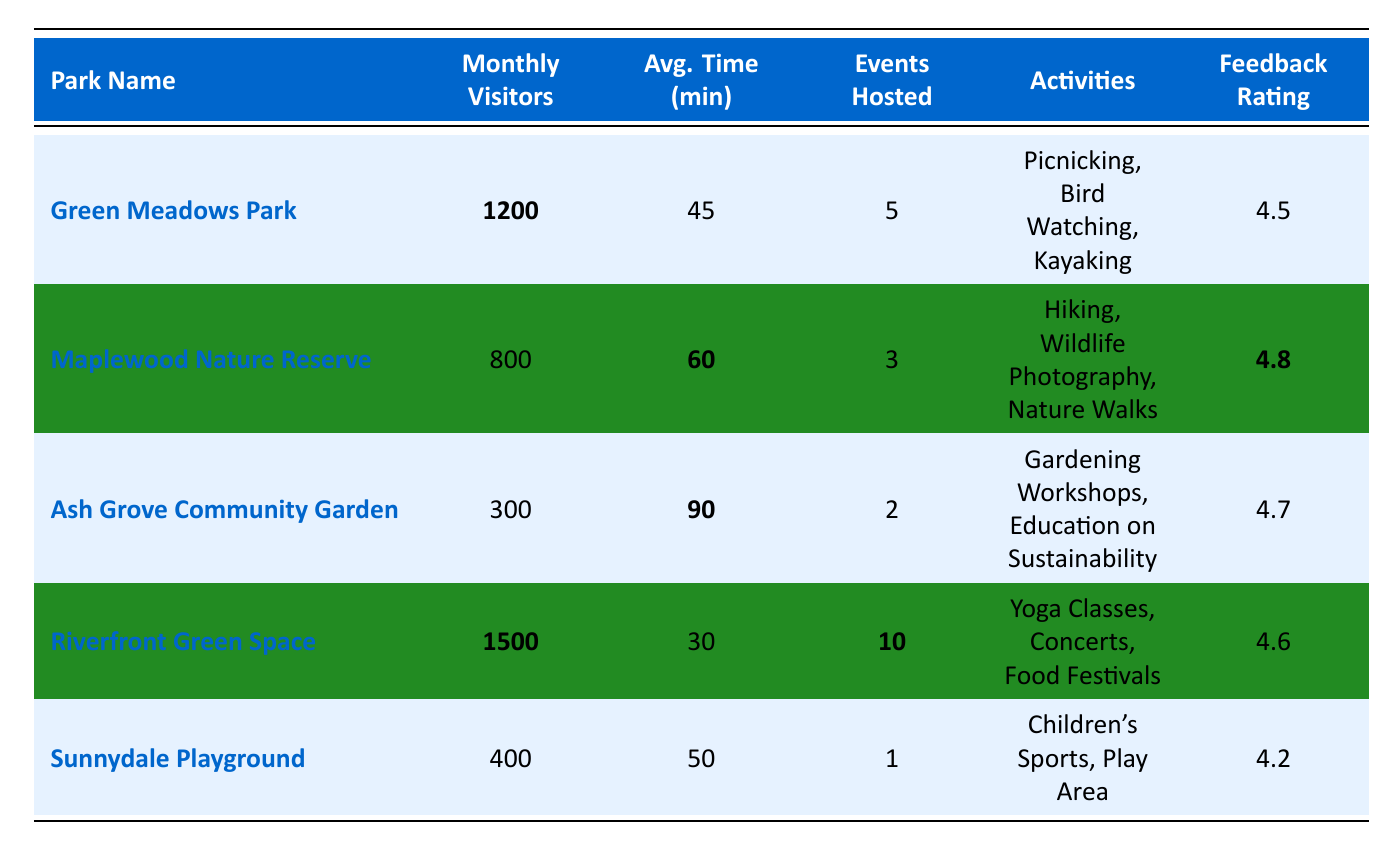What is the park with the highest monthly visitors? By examining the "Monthly Visitors" column, I identify the park with the most visitors, which is "Riverfront Green Space" with **1500** monthly visitors.
Answer: Riverfront Green Space What is the average time spent by visitors in "Ash Grove Community Garden"? The table directly provides the average time spent in "Ash Grove Community Garden" as **90** minutes.
Answer: 90 minutes How many events were hosted at "Green Meadows Park"? Looking at the "Events Hosted" column, "Green Meadows Park" hosted a total of **5** events.
Answer: 5 events Is the feedback rating for "Sunnydale Playground" greater than 4.5? The feedback rating for "Sunnydale Playground" is **4.2**, which is less than 4.5. Therefore, the statement is false.
Answer: No What is the total number of events hosted across all parks? I add the events hosted by each park: 5 (Green Meadows) + 3 (Maplewood) + 2 (Ash Grove) + 10 (Riverfront) + 1 (Sunnydale) = **21** events in total.
Answer: 21 events Which park has the longest average time spent by visitors, and what is that time? Comparing the "Avg. Time (min)" column, "Ash Grove Community Garden" has the longest average time spent at **90** minutes.
Answer: Ash Grove Community Garden, 90 minutes What is the difference in feedback ratings between "Maplewood Nature Reserve" and "Sunnydale Playground"? The feedback rating for "Maplewood Nature Reserve" is **4.8** and for "Sunnydale Playground" is **4.2**. The difference is **4.8 - 4.2 = 0.6**.
Answer: 0.6 If "Riverfront Green Space" had a 5% increase in monthly visitors, how many visitors would that be? A 5% increase on **1500** monthly visitors amounts to **1500 * 0.05 = 75**, so the new total would be **1500 + 75 = 1575** visitors.
Answer: 1575 visitors Which park offers the most variety of activities based on the table? The "Riverfront Green Space" offers three different activities: Yoga Classes, Concerts, and Food Festivals, while others offer fewer.
Answer: Riverfront Green Space What percentage of the total monthly visitors is represented by "Green Meadows Park"? The total monthly visitors from all parks is 1200 + 800 + 300 + 1500 + 400 = **3200**. The percentage for "Green Meadows Park" is (1200 / 3200) * 100 = 37.5%.
Answer: 37.5% 